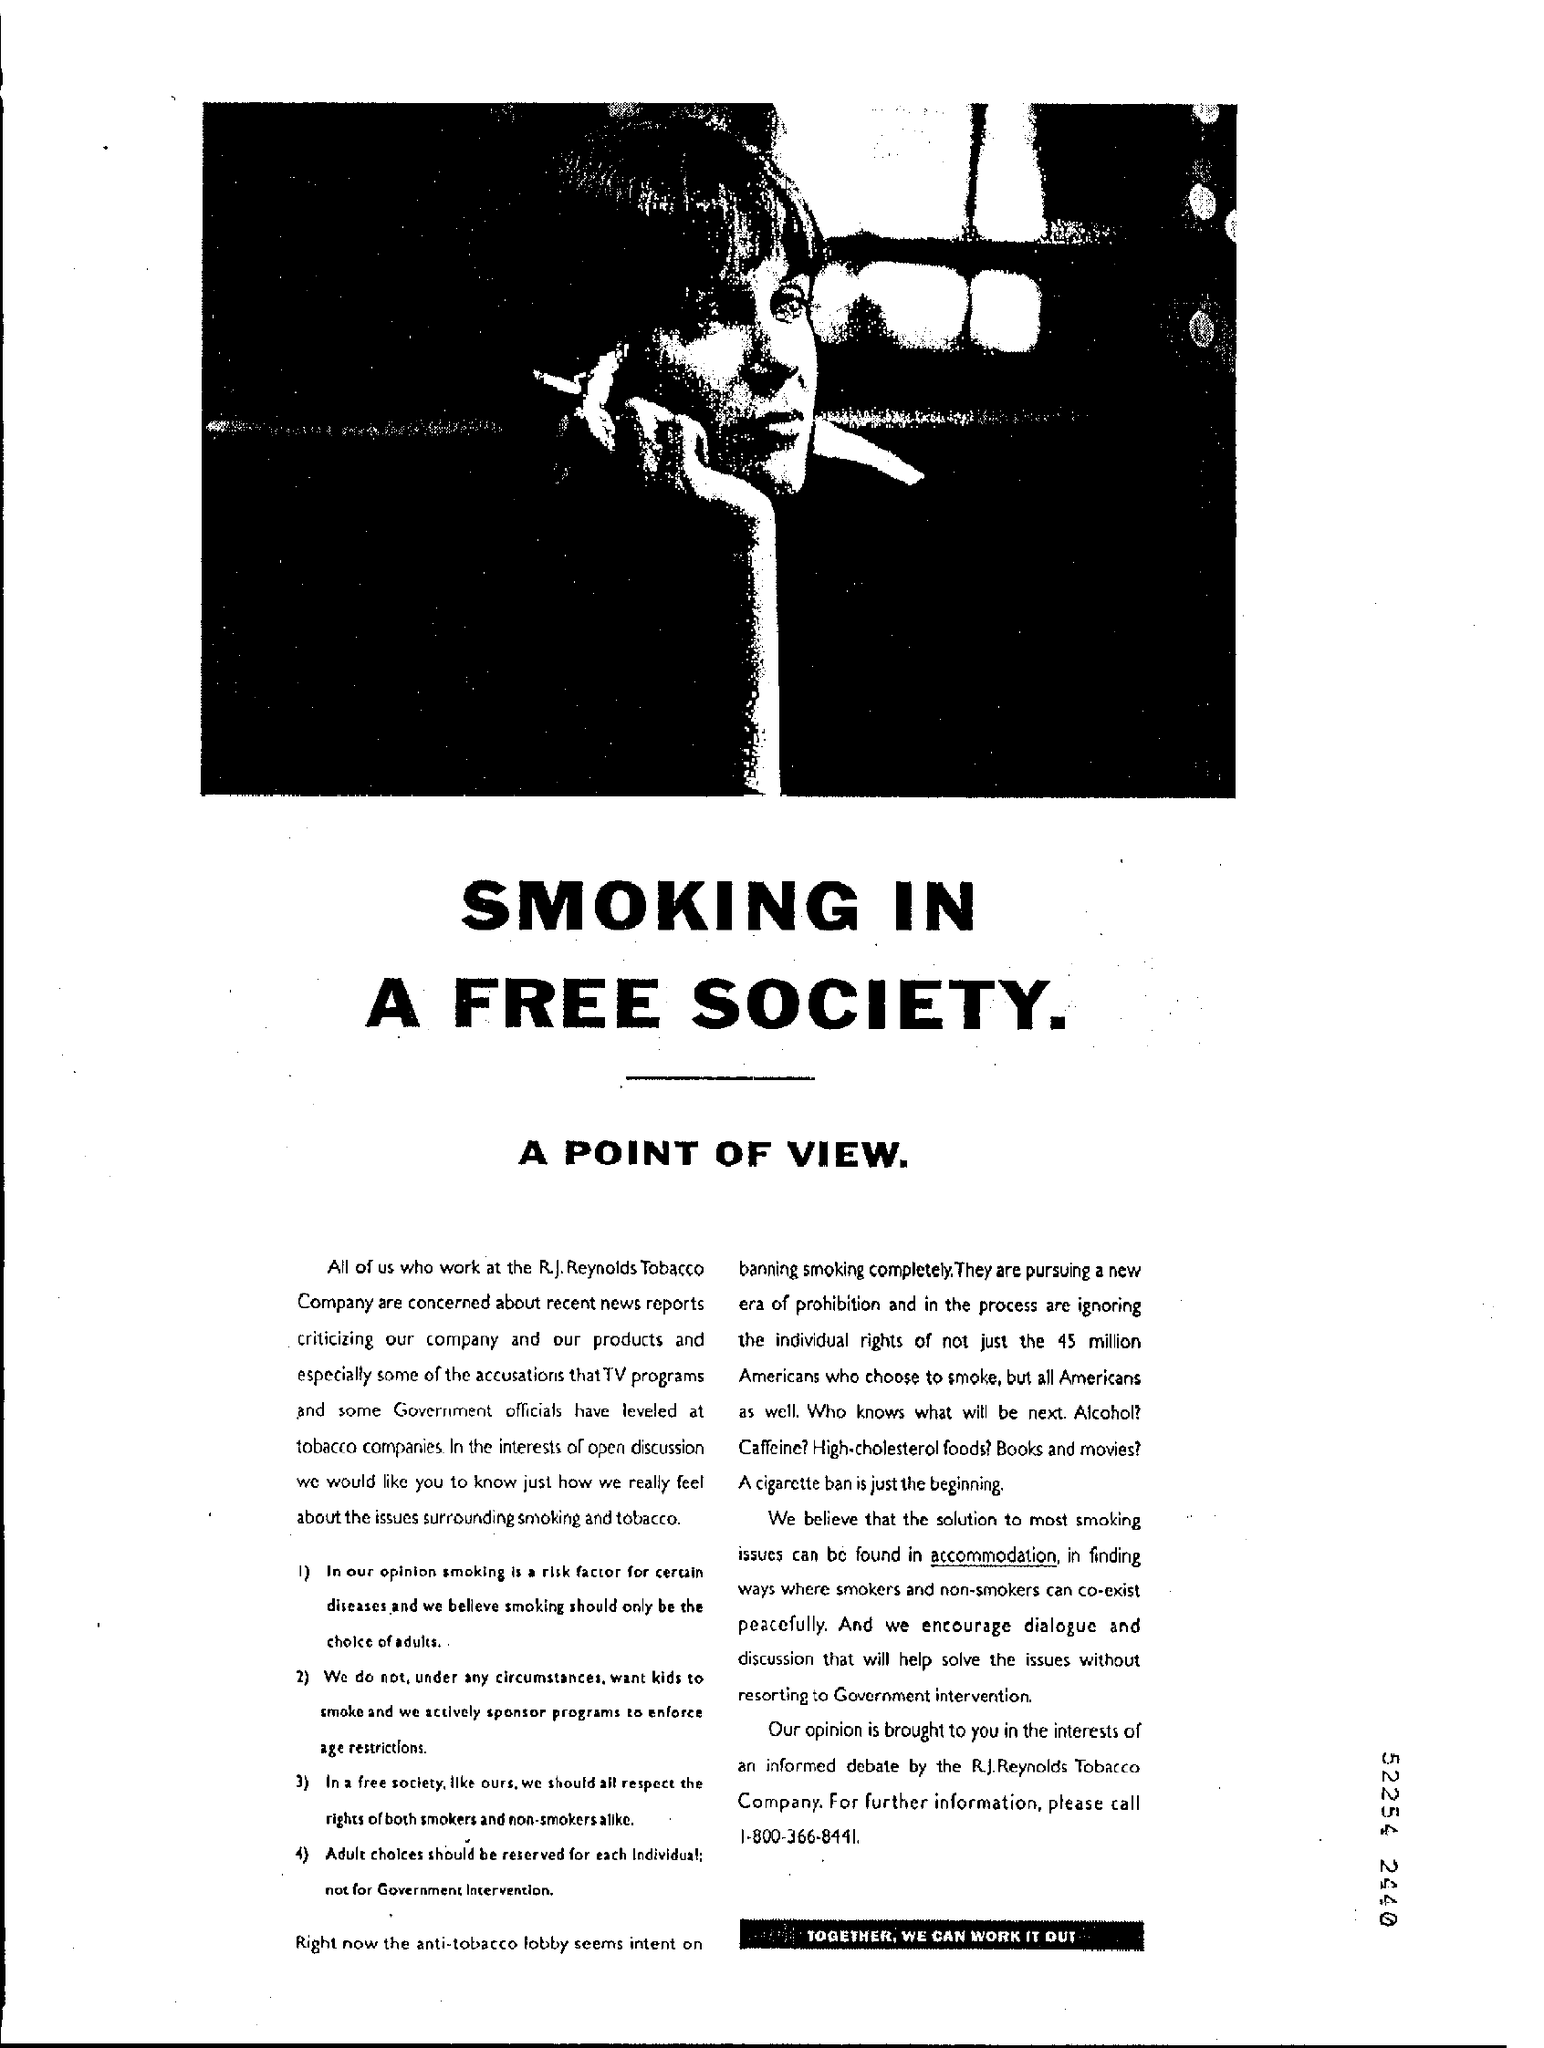What is the name of the company mentioned ?
Make the answer very short. R.J Reynolds tobacco company. What is the contact number mentioned ?
Give a very brief answer. 1-800-366-8441. 